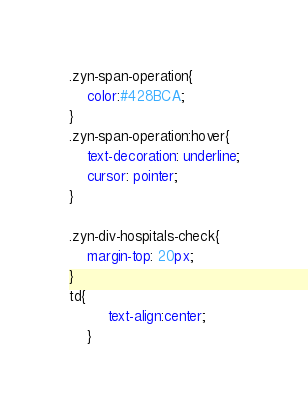Convert code to text. <code><loc_0><loc_0><loc_500><loc_500><_CSS_>.zyn-span-operation{
	color:#428BCA;
}
.zyn-span-operation:hover{
	text-decoration: underline;
	cursor: pointer;
}

.zyn-div-hospitals-check{
	margin-top: 20px;
}
td{
		 text-align:center;
	}</code> 